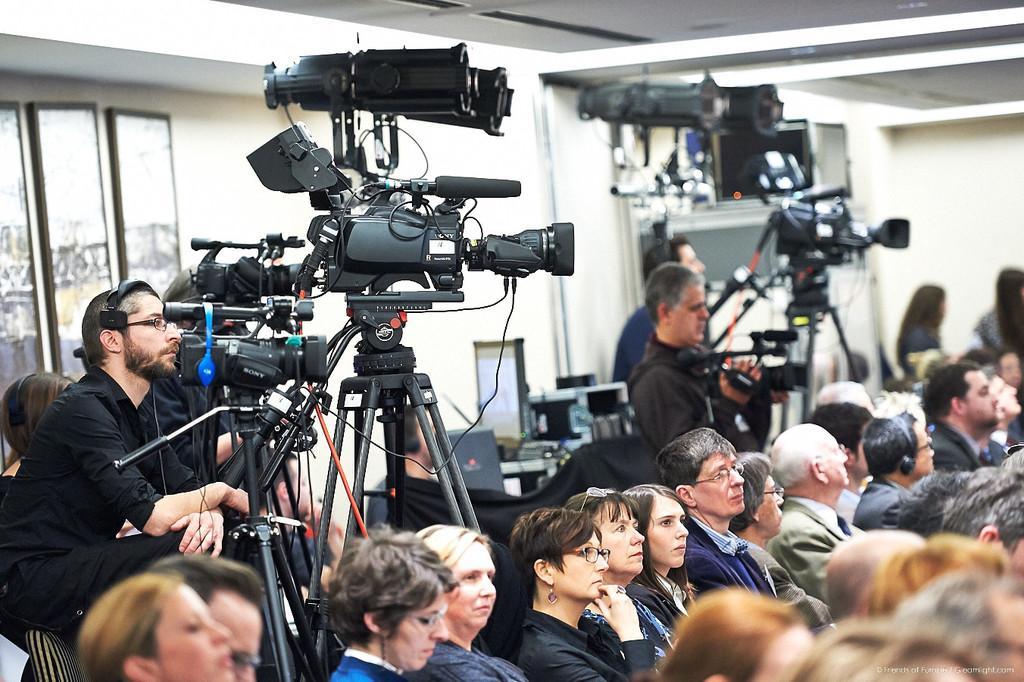In one or two sentences, can you explain what this image depicts? In this image there are group of people some of them are sitting, and some of them are holding cameras. And in the center there are some cameras and tables, on the tables there are some monitors and some objects. And in the background there is a wall, windows and some other objects. At the top there is ceiling. 